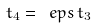Convert formula to latex. <formula><loc_0><loc_0><loc_500><loc_500>t _ { 4 } = \ e p s \, t _ { 3 }</formula> 